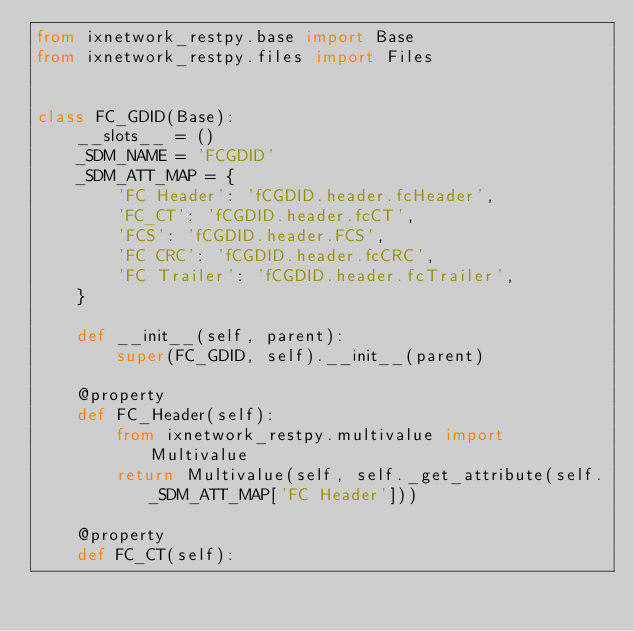Convert code to text. <code><loc_0><loc_0><loc_500><loc_500><_Python_>from ixnetwork_restpy.base import Base
from ixnetwork_restpy.files import Files


class FC_GDID(Base):
    __slots__ = ()
    _SDM_NAME = 'FCGDID'
    _SDM_ATT_MAP = {
        'FC Header': 'fCGDID.header.fcHeader',
        'FC_CT': 'fCGDID.header.fcCT',
        'FCS': 'fCGDID.header.FCS',
        'FC CRC': 'fCGDID.header.fcCRC',
        'FC Trailer': 'fCGDID.header.fcTrailer',
    }

    def __init__(self, parent):
        super(FC_GDID, self).__init__(parent)

    @property
    def FC_Header(self):
        from ixnetwork_restpy.multivalue import Multivalue
        return Multivalue(self, self._get_attribute(self._SDM_ATT_MAP['FC Header']))

    @property
    def FC_CT(self):</code> 